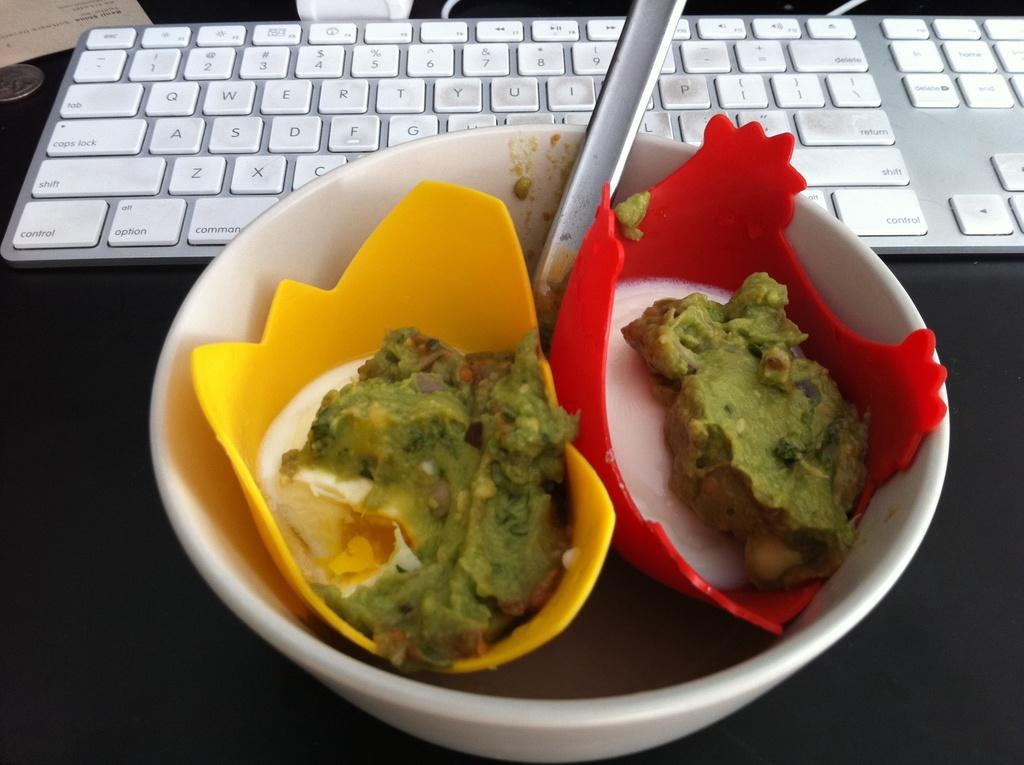What is in the bowl that is visible in the image? There is a bowl with food items in the image. What other object can be seen in the image besides the bowl? There is a keyboard in the image. Where are the bowl and keyboard placed? The bowl and keyboard are placed on a black platform. What type of cherry is used to decorate the keyboard in the image? There is no cherry present in the image, as the focus is on the bowl with food items and the keyboard. 